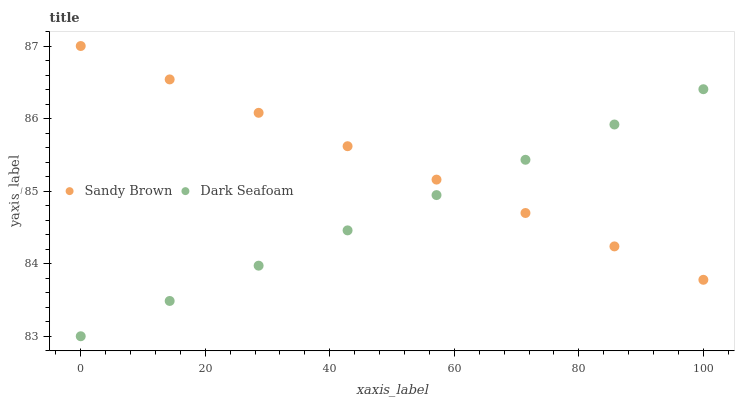Does Dark Seafoam have the minimum area under the curve?
Answer yes or no. Yes. Does Sandy Brown have the maximum area under the curve?
Answer yes or no. Yes. Does Sandy Brown have the minimum area under the curve?
Answer yes or no. No. Is Sandy Brown the smoothest?
Answer yes or no. Yes. Is Dark Seafoam the roughest?
Answer yes or no. Yes. Is Sandy Brown the roughest?
Answer yes or no. No. Does Dark Seafoam have the lowest value?
Answer yes or no. Yes. Does Sandy Brown have the lowest value?
Answer yes or no. No. Does Sandy Brown have the highest value?
Answer yes or no. Yes. Does Dark Seafoam intersect Sandy Brown?
Answer yes or no. Yes. Is Dark Seafoam less than Sandy Brown?
Answer yes or no. No. Is Dark Seafoam greater than Sandy Brown?
Answer yes or no. No. 